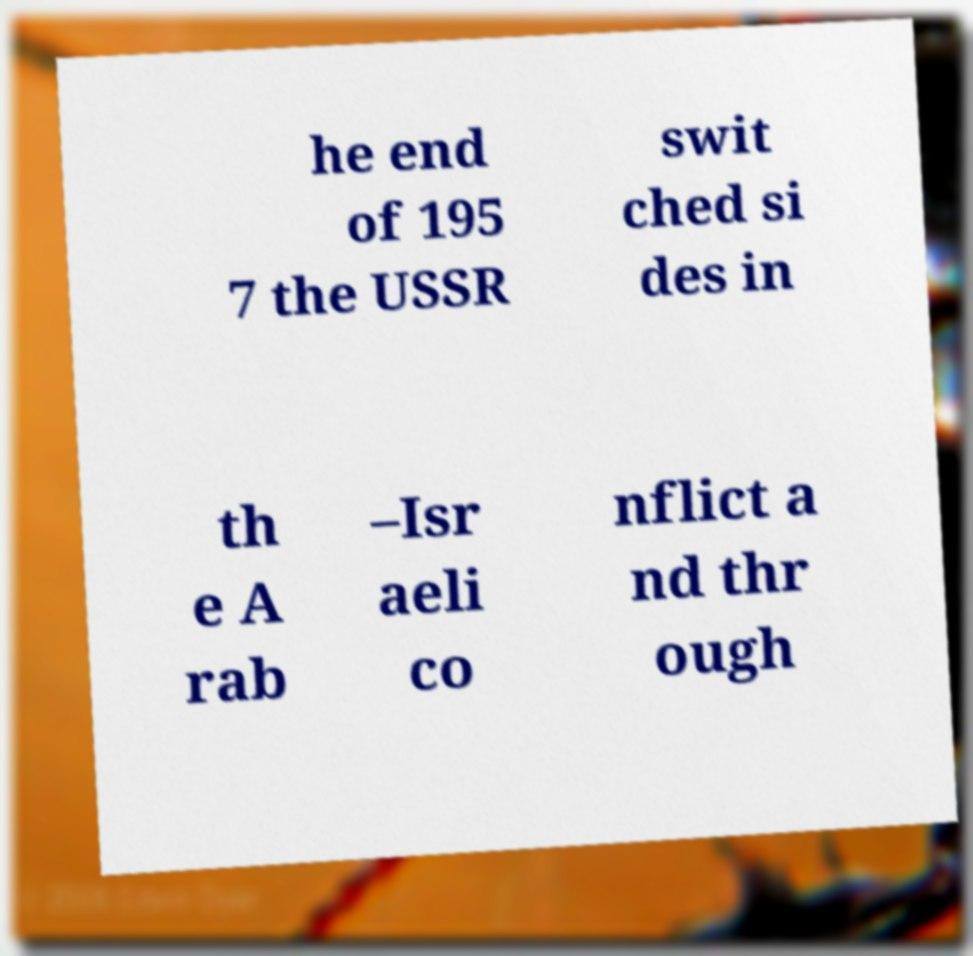For documentation purposes, I need the text within this image transcribed. Could you provide that? he end of 195 7 the USSR swit ched si des in th e A rab –Isr aeli co nflict a nd thr ough 